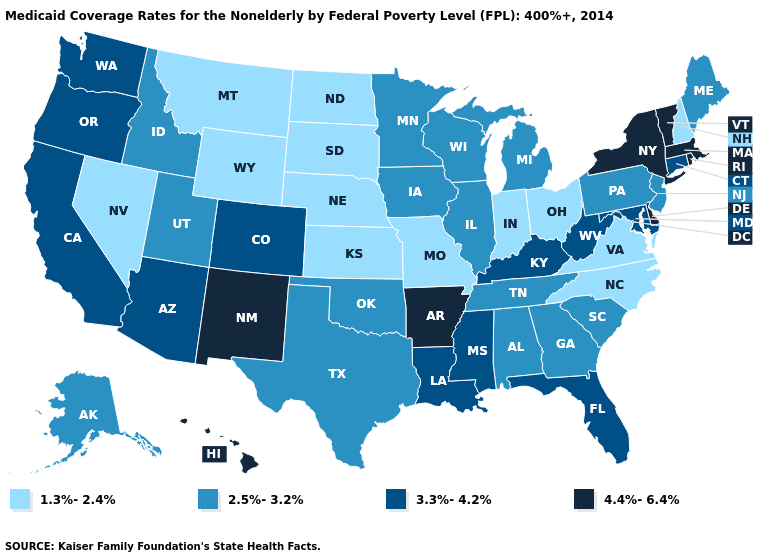Does Rhode Island have a higher value than Texas?
Short answer required. Yes. Name the states that have a value in the range 2.5%-3.2%?
Keep it brief. Alabama, Alaska, Georgia, Idaho, Illinois, Iowa, Maine, Michigan, Minnesota, New Jersey, Oklahoma, Pennsylvania, South Carolina, Tennessee, Texas, Utah, Wisconsin. What is the value of Kansas?
Give a very brief answer. 1.3%-2.4%. Which states have the lowest value in the USA?
Concise answer only. Indiana, Kansas, Missouri, Montana, Nebraska, Nevada, New Hampshire, North Carolina, North Dakota, Ohio, South Dakota, Virginia, Wyoming. Does Alaska have a higher value than Colorado?
Concise answer only. No. How many symbols are there in the legend?
Be succinct. 4. Does the map have missing data?
Keep it brief. No. Name the states that have a value in the range 1.3%-2.4%?
Give a very brief answer. Indiana, Kansas, Missouri, Montana, Nebraska, Nevada, New Hampshire, North Carolina, North Dakota, Ohio, South Dakota, Virginia, Wyoming. Which states have the lowest value in the USA?
Be succinct. Indiana, Kansas, Missouri, Montana, Nebraska, Nevada, New Hampshire, North Carolina, North Dakota, Ohio, South Dakota, Virginia, Wyoming. Name the states that have a value in the range 1.3%-2.4%?
Keep it brief. Indiana, Kansas, Missouri, Montana, Nebraska, Nevada, New Hampshire, North Carolina, North Dakota, Ohio, South Dakota, Virginia, Wyoming. What is the value of Iowa?
Quick response, please. 2.5%-3.2%. Does Idaho have the lowest value in the USA?
Be succinct. No. Name the states that have a value in the range 2.5%-3.2%?
Keep it brief. Alabama, Alaska, Georgia, Idaho, Illinois, Iowa, Maine, Michigan, Minnesota, New Jersey, Oklahoma, Pennsylvania, South Carolina, Tennessee, Texas, Utah, Wisconsin. Name the states that have a value in the range 1.3%-2.4%?
Write a very short answer. Indiana, Kansas, Missouri, Montana, Nebraska, Nevada, New Hampshire, North Carolina, North Dakota, Ohio, South Dakota, Virginia, Wyoming. What is the value of Kansas?
Write a very short answer. 1.3%-2.4%. 